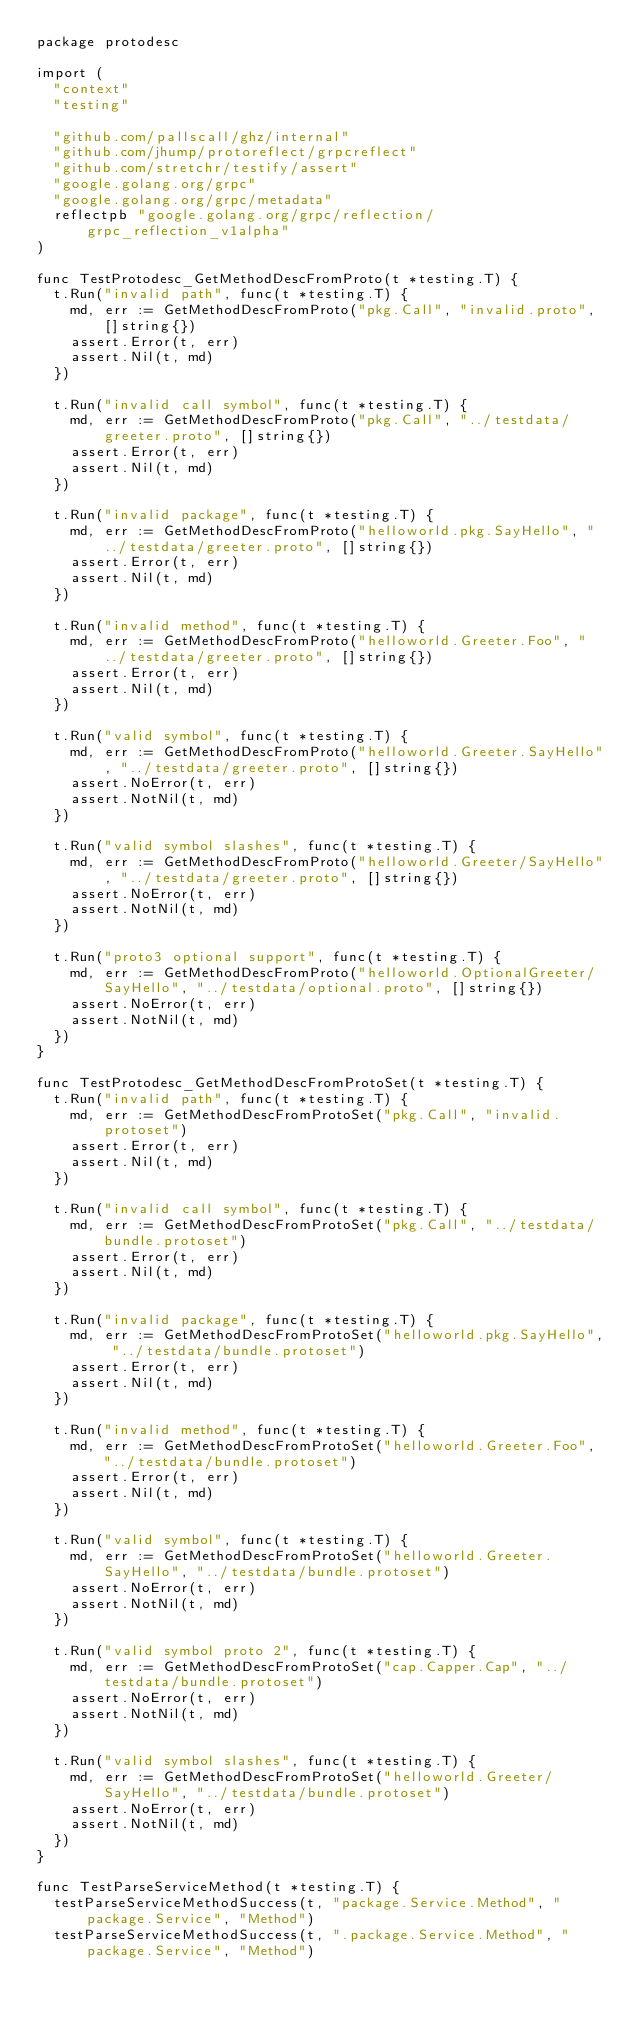<code> <loc_0><loc_0><loc_500><loc_500><_Go_>package protodesc

import (
	"context"
	"testing"

	"github.com/pallscall/ghz/internal"
	"github.com/jhump/protoreflect/grpcreflect"
	"github.com/stretchr/testify/assert"
	"google.golang.org/grpc"
	"google.golang.org/grpc/metadata"
	reflectpb "google.golang.org/grpc/reflection/grpc_reflection_v1alpha"
)

func TestProtodesc_GetMethodDescFromProto(t *testing.T) {
	t.Run("invalid path", func(t *testing.T) {
		md, err := GetMethodDescFromProto("pkg.Call", "invalid.proto", []string{})
		assert.Error(t, err)
		assert.Nil(t, md)
	})

	t.Run("invalid call symbol", func(t *testing.T) {
		md, err := GetMethodDescFromProto("pkg.Call", "../testdata/greeter.proto", []string{})
		assert.Error(t, err)
		assert.Nil(t, md)
	})

	t.Run("invalid package", func(t *testing.T) {
		md, err := GetMethodDescFromProto("helloworld.pkg.SayHello", "../testdata/greeter.proto", []string{})
		assert.Error(t, err)
		assert.Nil(t, md)
	})

	t.Run("invalid method", func(t *testing.T) {
		md, err := GetMethodDescFromProto("helloworld.Greeter.Foo", "../testdata/greeter.proto", []string{})
		assert.Error(t, err)
		assert.Nil(t, md)
	})

	t.Run("valid symbol", func(t *testing.T) {
		md, err := GetMethodDescFromProto("helloworld.Greeter.SayHello", "../testdata/greeter.proto", []string{})
		assert.NoError(t, err)
		assert.NotNil(t, md)
	})

	t.Run("valid symbol slashes", func(t *testing.T) {
		md, err := GetMethodDescFromProto("helloworld.Greeter/SayHello", "../testdata/greeter.proto", []string{})
		assert.NoError(t, err)
		assert.NotNil(t, md)
	})

	t.Run("proto3 optional support", func(t *testing.T) {
		md, err := GetMethodDescFromProto("helloworld.OptionalGreeter/SayHello", "../testdata/optional.proto", []string{})
		assert.NoError(t, err)
		assert.NotNil(t, md)
	})
}

func TestProtodesc_GetMethodDescFromProtoSet(t *testing.T) {
	t.Run("invalid path", func(t *testing.T) {
		md, err := GetMethodDescFromProtoSet("pkg.Call", "invalid.protoset")
		assert.Error(t, err)
		assert.Nil(t, md)
	})

	t.Run("invalid call symbol", func(t *testing.T) {
		md, err := GetMethodDescFromProtoSet("pkg.Call", "../testdata/bundle.protoset")
		assert.Error(t, err)
		assert.Nil(t, md)
	})

	t.Run("invalid package", func(t *testing.T) {
		md, err := GetMethodDescFromProtoSet("helloworld.pkg.SayHello", "../testdata/bundle.protoset")
		assert.Error(t, err)
		assert.Nil(t, md)
	})

	t.Run("invalid method", func(t *testing.T) {
		md, err := GetMethodDescFromProtoSet("helloworld.Greeter.Foo", "../testdata/bundle.protoset")
		assert.Error(t, err)
		assert.Nil(t, md)
	})

	t.Run("valid symbol", func(t *testing.T) {
		md, err := GetMethodDescFromProtoSet("helloworld.Greeter.SayHello", "../testdata/bundle.protoset")
		assert.NoError(t, err)
		assert.NotNil(t, md)
	})

	t.Run("valid symbol proto 2", func(t *testing.T) {
		md, err := GetMethodDescFromProtoSet("cap.Capper.Cap", "../testdata/bundle.protoset")
		assert.NoError(t, err)
		assert.NotNil(t, md)
	})

	t.Run("valid symbol slashes", func(t *testing.T) {
		md, err := GetMethodDescFromProtoSet("helloworld.Greeter/SayHello", "../testdata/bundle.protoset")
		assert.NoError(t, err)
		assert.NotNil(t, md)
	})
}

func TestParseServiceMethod(t *testing.T) {
	testParseServiceMethodSuccess(t, "package.Service.Method", "package.Service", "Method")
	testParseServiceMethodSuccess(t, ".package.Service.Method", "package.Service", "Method")</code> 